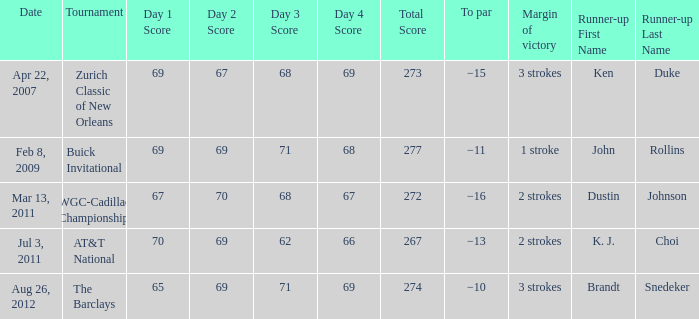A tournament on which date has a margin of victory of 2 strokes and a par of −16? Mar 13, 2011. 